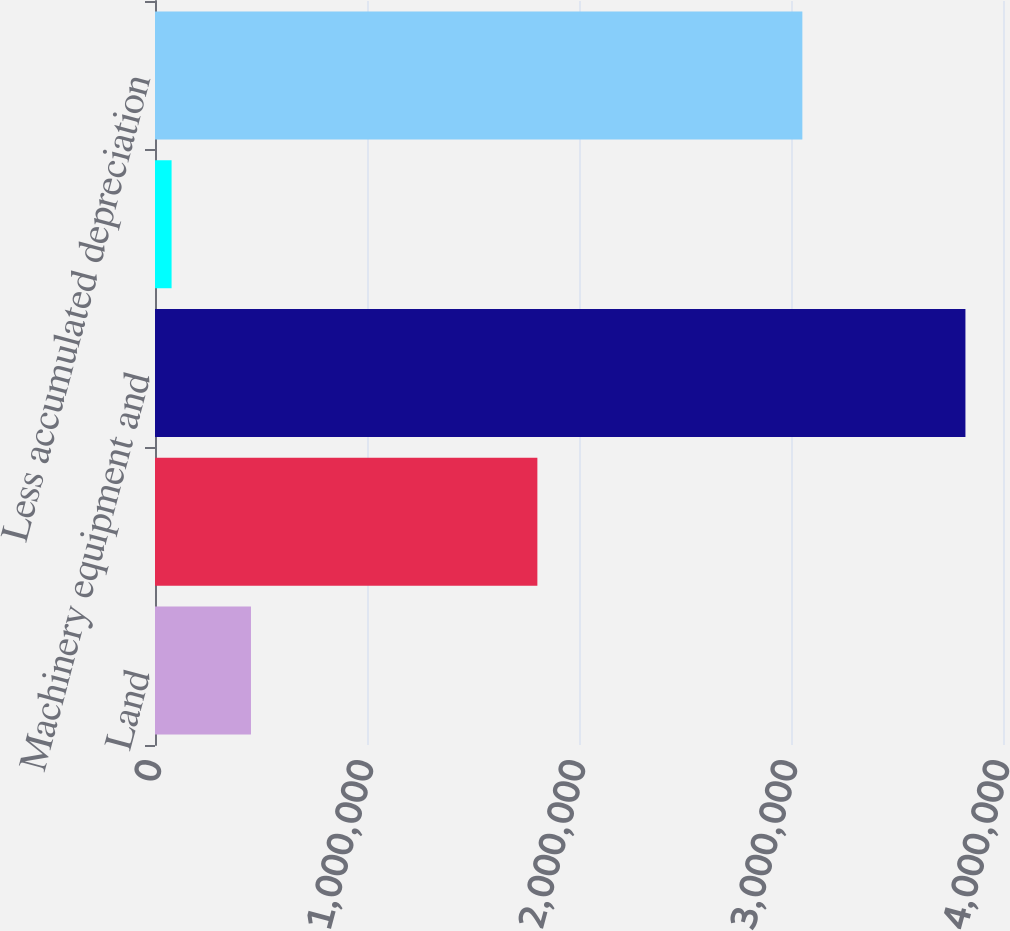Convert chart to OTSL. <chart><loc_0><loc_0><loc_500><loc_500><bar_chart><fcel>Land<fcel>Buildings<fcel>Machinery equipment and<fcel>Leasehold improvements<fcel>Less accumulated depreciation<nl><fcel>452704<fcel>1.80362e+06<fcel>3.82278e+06<fcel>78251<fcel>3.05352e+06<nl></chart> 